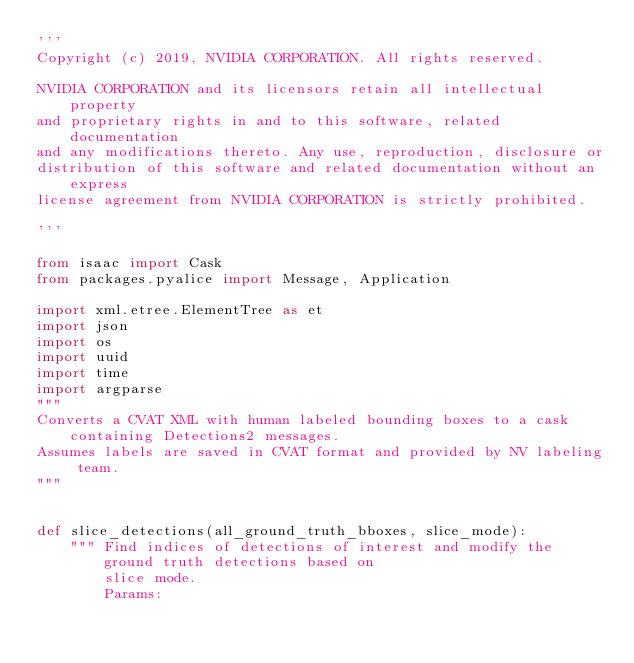Convert code to text. <code><loc_0><loc_0><loc_500><loc_500><_Python_>'''
Copyright (c) 2019, NVIDIA CORPORATION. All rights reserved.

NVIDIA CORPORATION and its licensors retain all intellectual property
and proprietary rights in and to this software, related documentation
and any modifications thereto. Any use, reproduction, disclosure or
distribution of this software and related documentation without an express
license agreement from NVIDIA CORPORATION is strictly prohibited.

'''

from isaac import Cask
from packages.pyalice import Message, Application

import xml.etree.ElementTree as et
import json
import os
import uuid
import time
import argparse
"""
Converts a CVAT XML with human labeled bounding boxes to a cask containing Detections2 messages.
Assumes labels are saved in CVAT format and provided by NV labeling team.
"""


def slice_detections(all_ground_truth_bboxes, slice_mode):
    """ Find indices of detections of interest and modify the ground truth detections based on
        slice mode.
        Params:</code> 